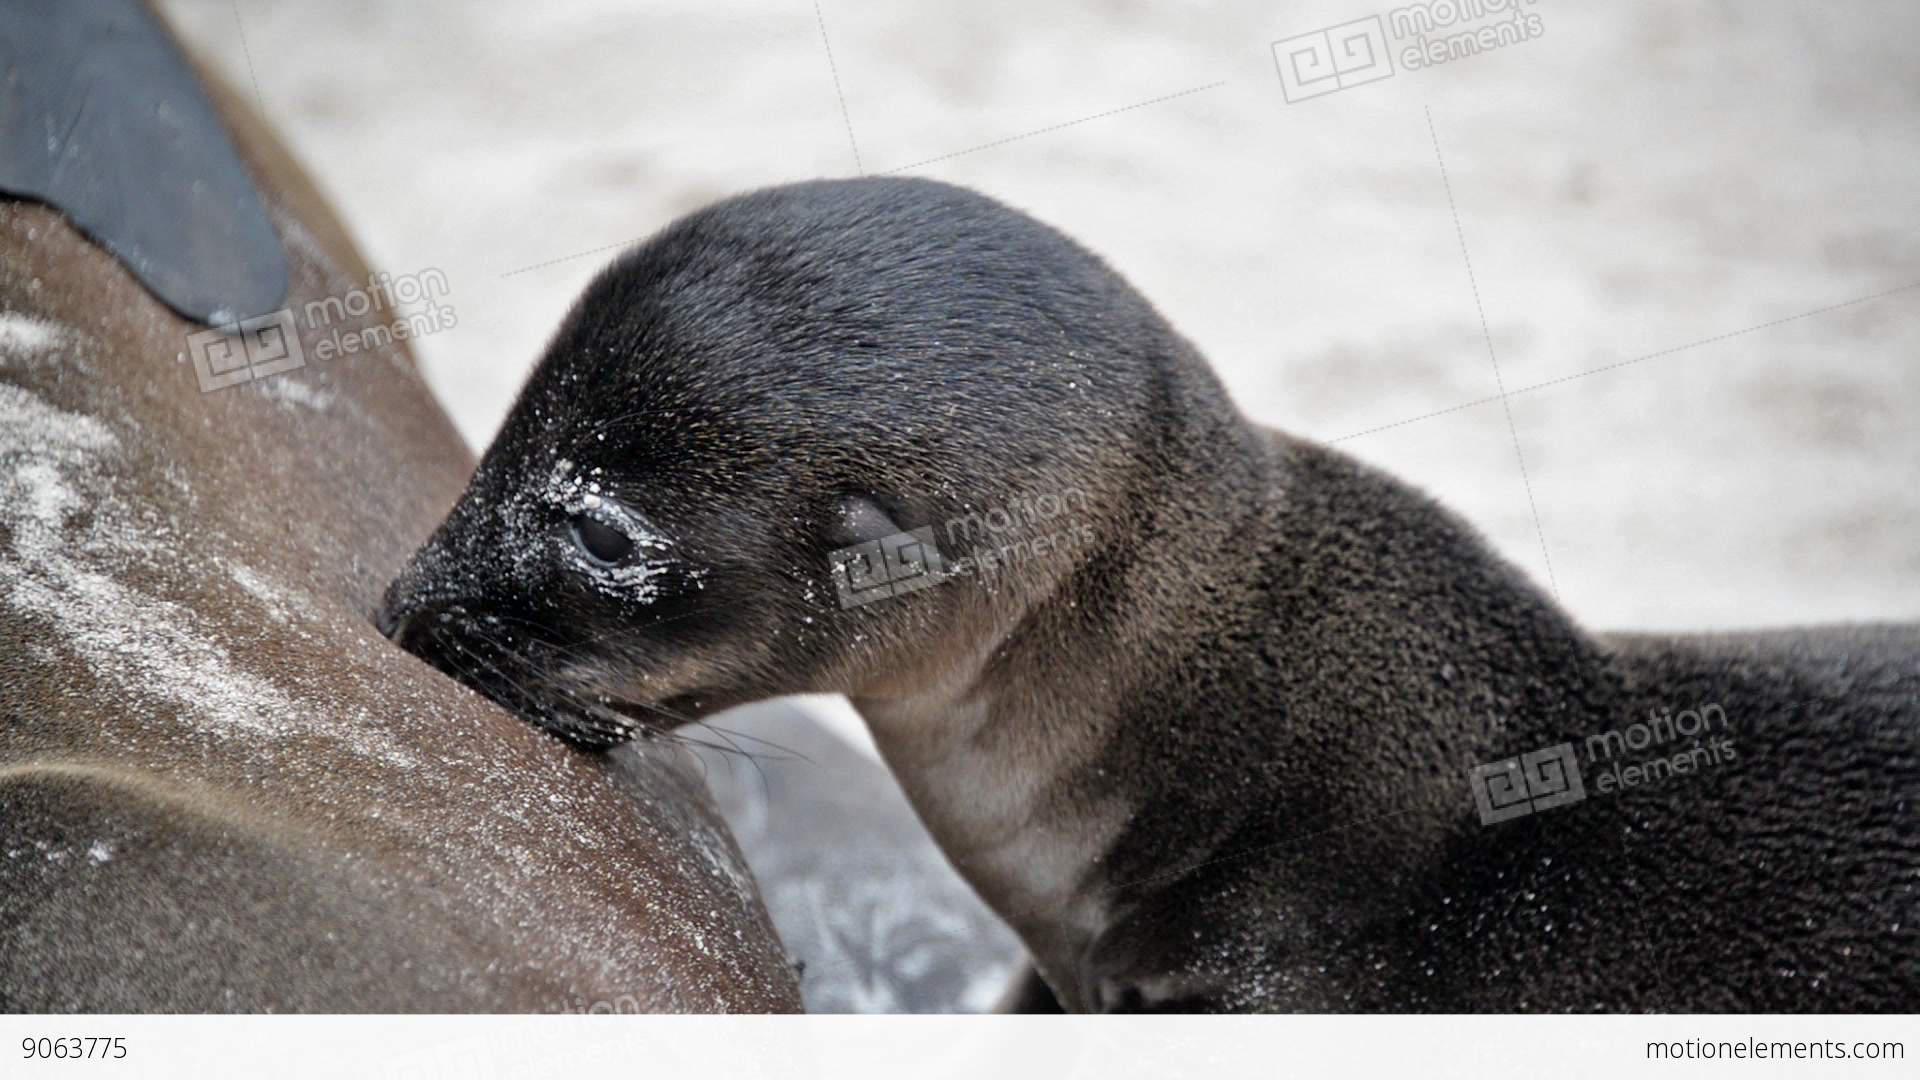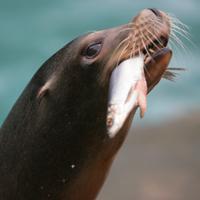The first image is the image on the left, the second image is the image on the right. Analyze the images presented: Is the assertion "The right image shows a seal with a fish held in its mouth." valid? Answer yes or no. Yes. The first image is the image on the left, the second image is the image on the right. Analyze the images presented: Is the assertion "At least one seal is eating a fish." valid? Answer yes or no. Yes. 